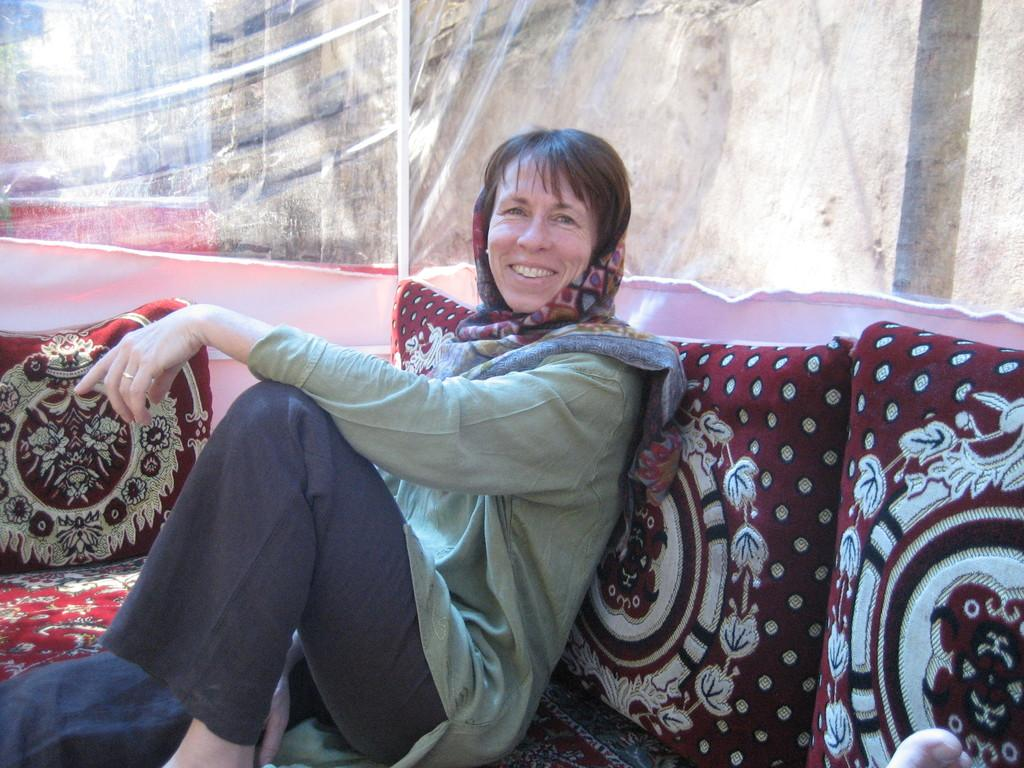What type of furniture is the person sitting on in the image? There is a person sitting on a couch in the image. What is the person's facial expression in the image? The person is smiling in the image. What can be seen in the background of the image? There is a cloth and a wall visible in the background of the image. What type of seating accessories are present in the image? There are cushions in the image. How many sisters are sitting on the couch in the image? There is no mention of sisters in the image; only one person is sitting on the couch. What reason does the person have for sitting on the couch in the image? The image does not provide any information about the person's reason for sitting on the couch. 